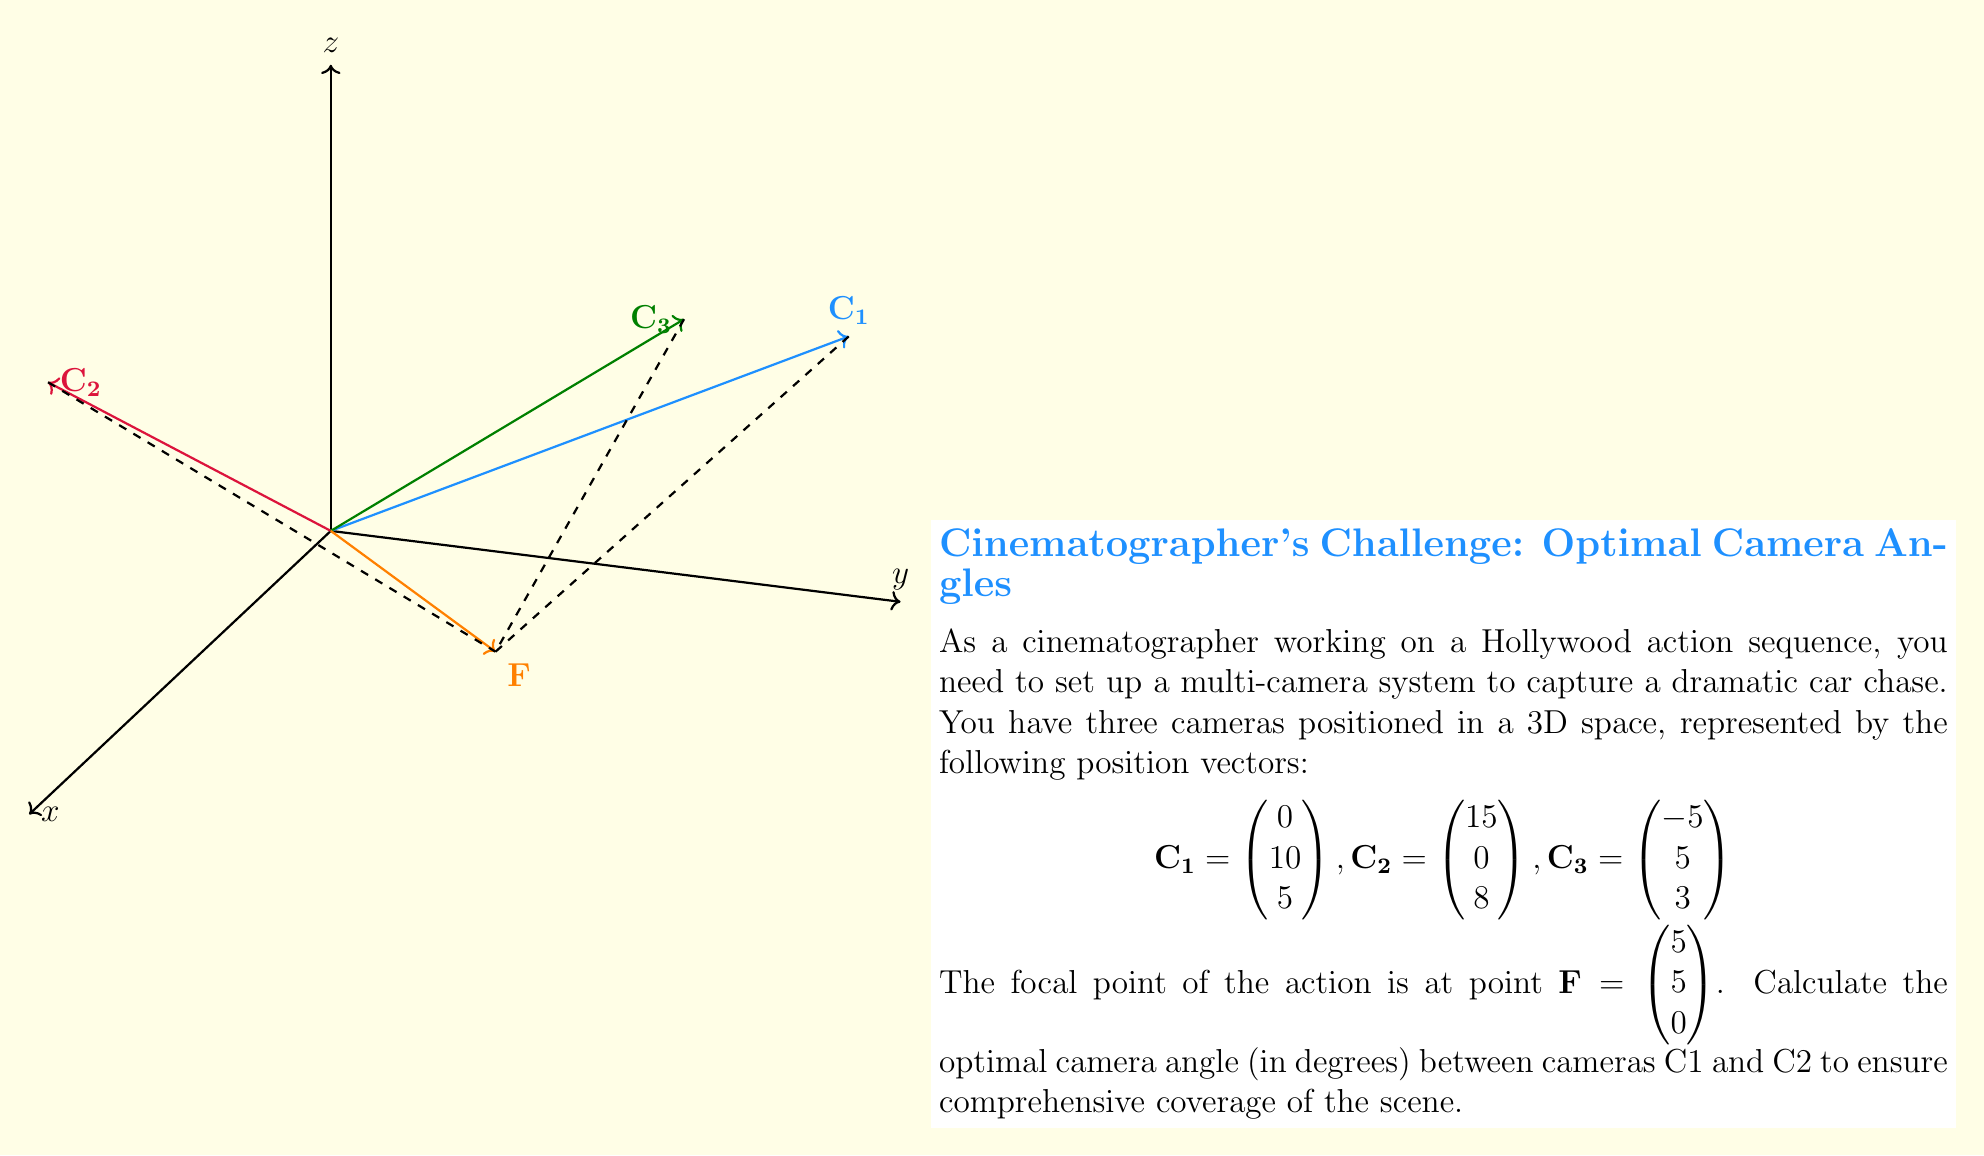Could you help me with this problem? To find the angle between cameras C1 and C2 relative to the focal point F, we'll follow these steps:

1) First, we need to calculate the vectors from the focal point to each camera:
   $$\vec{FC_1} = \mathbf{C_1} - \mathbf{F} = \begin{pmatrix} 0-5 \\ 10-5 \\ 5-0 \end{pmatrix} = \begin{pmatrix} -5 \\ 5 \\ 5 \end{pmatrix}$$
   $$\vec{FC_2} = \mathbf{C_2} - \mathbf{F} = \begin{pmatrix} 15-5 \\ 0-5 \\ 8-0 \end{pmatrix} = \begin{pmatrix} 10 \\ -5 \\ 8 \end{pmatrix}$$

2) Next, we'll use the dot product formula to find the angle between these vectors:
   $$\cos \theta = \frac{\vec{FC_1} \cdot \vec{FC_2}}{|\vec{FC_1}| |\vec{FC_2}|}$$

3) Calculate the dot product $\vec{FC_1} \cdot \vec{FC_2}$:
   $$\vec{FC_1} \cdot \vec{FC_2} = (-5)(10) + (5)(-5) + (5)(8) = -50 - 25 + 40 = -35$$

4) Calculate the magnitudes of the vectors:
   $$|\vec{FC_1}| = \sqrt{(-5)^2 + 5^2 + 5^2} = \sqrt{75} = 5\sqrt{3}$$
   $$|\vec{FC_2}| = \sqrt{10^2 + (-5)^2 + 8^2} = \sqrt{225} = 15$$

5) Substitute into the cosine formula:
   $$\cos \theta = \frac{-35}{(5\sqrt{3})(15)} = \frac{-35}{75\sqrt{3}} = -\frac{7}{15\sqrt{3}}$$

6) Take the inverse cosine (arccos) of both sides:
   $$\theta = \arccos(-\frac{7}{15\sqrt{3}})$$

7) Convert to degrees:
   $$\theta = \arccos(-\frac{7}{15\sqrt{3}}) \cdot \frac{180}{\pi} \approx 106.26°$$
Answer: $106.26°$ 